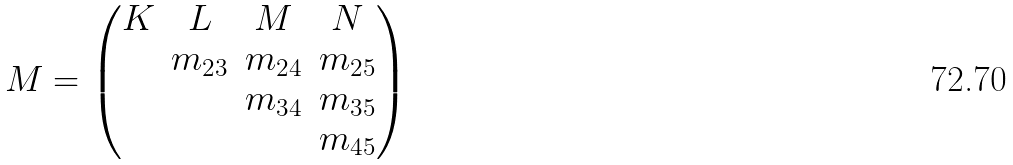Convert formula to latex. <formula><loc_0><loc_0><loc_500><loc_500>M = \begin{pmatrix} K & L & M & N \\ & m _ { 2 3 } & m _ { 2 4 } & m _ { 2 5 } \\ & & m _ { 3 4 } & m _ { 3 5 } \\ & & & m _ { 4 5 } \end{pmatrix}</formula> 